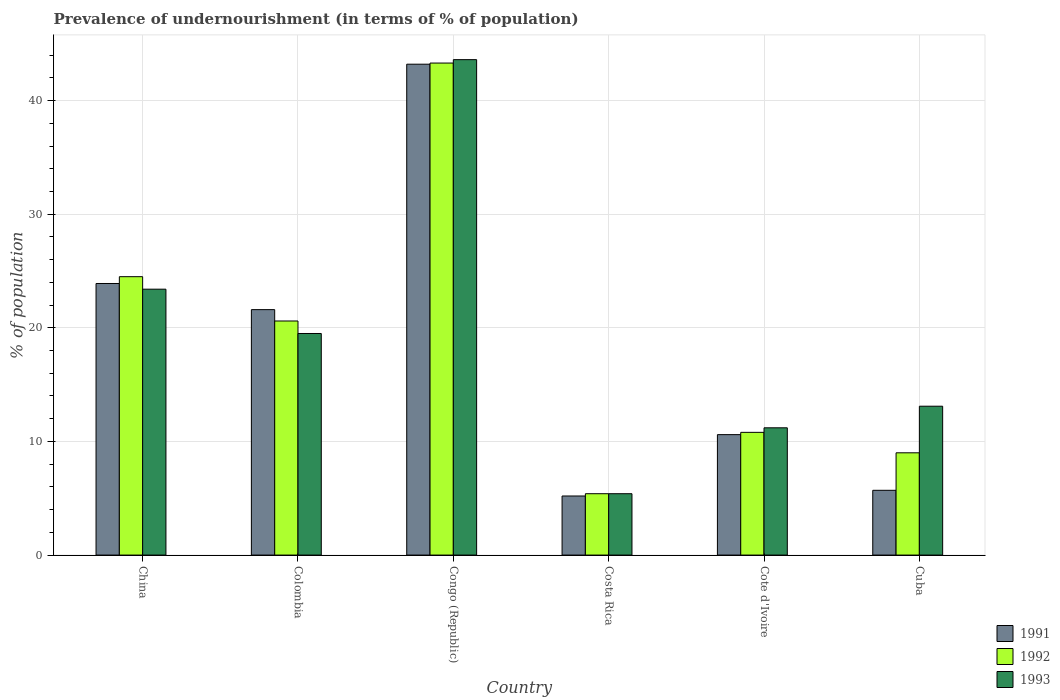Are the number of bars on each tick of the X-axis equal?
Provide a short and direct response. Yes. How many bars are there on the 6th tick from the left?
Ensure brevity in your answer.  3. What is the label of the 5th group of bars from the left?
Give a very brief answer. Cote d'Ivoire. Across all countries, what is the maximum percentage of undernourished population in 1991?
Provide a succinct answer. 43.2. Across all countries, what is the minimum percentage of undernourished population in 1993?
Provide a short and direct response. 5.4. In which country was the percentage of undernourished population in 1992 maximum?
Offer a terse response. Congo (Republic). What is the total percentage of undernourished population in 1992 in the graph?
Offer a terse response. 113.6. What is the difference between the percentage of undernourished population in 1992 in Congo (Republic) and that in Costa Rica?
Provide a short and direct response. 37.9. What is the difference between the percentage of undernourished population in 1991 in Congo (Republic) and the percentage of undernourished population in 1992 in Cote d'Ivoire?
Give a very brief answer. 32.4. What is the average percentage of undernourished population in 1993 per country?
Keep it short and to the point. 19.37. What is the difference between the percentage of undernourished population of/in 1993 and percentage of undernourished population of/in 1991 in Congo (Republic)?
Offer a terse response. 0.4. What is the ratio of the percentage of undernourished population in 1992 in China to that in Colombia?
Give a very brief answer. 1.19. What is the difference between the highest and the second highest percentage of undernourished population in 1993?
Your answer should be very brief. -24.1. What is the difference between the highest and the lowest percentage of undernourished population in 1991?
Give a very brief answer. 38. What does the 3rd bar from the left in Costa Rica represents?
Ensure brevity in your answer.  1993. What does the 3rd bar from the right in Cuba represents?
Offer a terse response. 1991. Is it the case that in every country, the sum of the percentage of undernourished population in 1992 and percentage of undernourished population in 1993 is greater than the percentage of undernourished population in 1991?
Keep it short and to the point. Yes. How many bars are there?
Your answer should be very brief. 18. Does the graph contain any zero values?
Offer a terse response. No. Does the graph contain grids?
Provide a succinct answer. Yes. Where does the legend appear in the graph?
Offer a terse response. Bottom right. How many legend labels are there?
Provide a succinct answer. 3. What is the title of the graph?
Your answer should be compact. Prevalence of undernourishment (in terms of % of population). Does "2002" appear as one of the legend labels in the graph?
Your response must be concise. No. What is the label or title of the X-axis?
Your response must be concise. Country. What is the label or title of the Y-axis?
Your response must be concise. % of population. What is the % of population in 1991 in China?
Offer a terse response. 23.9. What is the % of population of 1993 in China?
Your answer should be compact. 23.4. What is the % of population of 1991 in Colombia?
Give a very brief answer. 21.6. What is the % of population in 1992 in Colombia?
Ensure brevity in your answer.  20.6. What is the % of population in 1991 in Congo (Republic)?
Offer a terse response. 43.2. What is the % of population in 1992 in Congo (Republic)?
Offer a very short reply. 43.3. What is the % of population of 1993 in Congo (Republic)?
Your response must be concise. 43.6. What is the % of population in 1992 in Costa Rica?
Make the answer very short. 5.4. What is the % of population of 1993 in Costa Rica?
Provide a succinct answer. 5.4. What is the % of population of 1991 in Cote d'Ivoire?
Provide a short and direct response. 10.6. What is the % of population in 1993 in Cote d'Ivoire?
Provide a short and direct response. 11.2. What is the % of population of 1991 in Cuba?
Your answer should be very brief. 5.7. What is the % of population of 1992 in Cuba?
Ensure brevity in your answer.  9. What is the % of population of 1993 in Cuba?
Keep it short and to the point. 13.1. Across all countries, what is the maximum % of population of 1991?
Ensure brevity in your answer.  43.2. Across all countries, what is the maximum % of population of 1992?
Keep it short and to the point. 43.3. Across all countries, what is the maximum % of population of 1993?
Offer a very short reply. 43.6. Across all countries, what is the minimum % of population of 1991?
Your answer should be compact. 5.2. Across all countries, what is the minimum % of population in 1993?
Provide a succinct answer. 5.4. What is the total % of population of 1991 in the graph?
Provide a short and direct response. 110.2. What is the total % of population in 1992 in the graph?
Keep it short and to the point. 113.6. What is the total % of population of 1993 in the graph?
Provide a succinct answer. 116.2. What is the difference between the % of population in 1991 in China and that in Congo (Republic)?
Provide a short and direct response. -19.3. What is the difference between the % of population of 1992 in China and that in Congo (Republic)?
Give a very brief answer. -18.8. What is the difference between the % of population of 1993 in China and that in Congo (Republic)?
Keep it short and to the point. -20.2. What is the difference between the % of population of 1991 in China and that in Costa Rica?
Your answer should be very brief. 18.7. What is the difference between the % of population of 1992 in China and that in Costa Rica?
Provide a short and direct response. 19.1. What is the difference between the % of population in 1993 in China and that in Costa Rica?
Your answer should be compact. 18. What is the difference between the % of population in 1992 in China and that in Cote d'Ivoire?
Ensure brevity in your answer.  13.7. What is the difference between the % of population in 1992 in China and that in Cuba?
Offer a very short reply. 15.5. What is the difference between the % of population of 1991 in Colombia and that in Congo (Republic)?
Your answer should be compact. -21.6. What is the difference between the % of population in 1992 in Colombia and that in Congo (Republic)?
Ensure brevity in your answer.  -22.7. What is the difference between the % of population in 1993 in Colombia and that in Congo (Republic)?
Ensure brevity in your answer.  -24.1. What is the difference between the % of population of 1991 in Colombia and that in Cote d'Ivoire?
Your response must be concise. 11. What is the difference between the % of population in 1992 in Colombia and that in Cuba?
Your response must be concise. 11.6. What is the difference between the % of population in 1991 in Congo (Republic) and that in Costa Rica?
Ensure brevity in your answer.  38. What is the difference between the % of population in 1992 in Congo (Republic) and that in Costa Rica?
Your response must be concise. 37.9. What is the difference between the % of population in 1993 in Congo (Republic) and that in Costa Rica?
Keep it short and to the point. 38.2. What is the difference between the % of population in 1991 in Congo (Republic) and that in Cote d'Ivoire?
Your answer should be very brief. 32.6. What is the difference between the % of population in 1992 in Congo (Republic) and that in Cote d'Ivoire?
Offer a terse response. 32.5. What is the difference between the % of population in 1993 in Congo (Republic) and that in Cote d'Ivoire?
Give a very brief answer. 32.4. What is the difference between the % of population of 1991 in Congo (Republic) and that in Cuba?
Your answer should be very brief. 37.5. What is the difference between the % of population in 1992 in Congo (Republic) and that in Cuba?
Keep it short and to the point. 34.3. What is the difference between the % of population in 1993 in Congo (Republic) and that in Cuba?
Your response must be concise. 30.5. What is the difference between the % of population of 1993 in Costa Rica and that in Cote d'Ivoire?
Your response must be concise. -5.8. What is the difference between the % of population in 1991 in Cote d'Ivoire and that in Cuba?
Give a very brief answer. 4.9. What is the difference between the % of population of 1992 in Cote d'Ivoire and that in Cuba?
Make the answer very short. 1.8. What is the difference between the % of population of 1993 in Cote d'Ivoire and that in Cuba?
Make the answer very short. -1.9. What is the difference between the % of population of 1991 in China and the % of population of 1992 in Colombia?
Your response must be concise. 3.3. What is the difference between the % of population in 1992 in China and the % of population in 1993 in Colombia?
Make the answer very short. 5. What is the difference between the % of population in 1991 in China and the % of population in 1992 in Congo (Republic)?
Offer a terse response. -19.4. What is the difference between the % of population of 1991 in China and the % of population of 1993 in Congo (Republic)?
Your answer should be compact. -19.7. What is the difference between the % of population of 1992 in China and the % of population of 1993 in Congo (Republic)?
Provide a succinct answer. -19.1. What is the difference between the % of population of 1991 in China and the % of population of 1992 in Costa Rica?
Keep it short and to the point. 18.5. What is the difference between the % of population of 1991 in China and the % of population of 1993 in Costa Rica?
Make the answer very short. 18.5. What is the difference between the % of population of 1992 in China and the % of population of 1993 in Costa Rica?
Provide a succinct answer. 19.1. What is the difference between the % of population of 1991 in China and the % of population of 1992 in Cote d'Ivoire?
Your response must be concise. 13.1. What is the difference between the % of population in 1991 in China and the % of population in 1993 in Cote d'Ivoire?
Ensure brevity in your answer.  12.7. What is the difference between the % of population of 1991 in China and the % of population of 1992 in Cuba?
Your answer should be compact. 14.9. What is the difference between the % of population in 1991 in China and the % of population in 1993 in Cuba?
Provide a short and direct response. 10.8. What is the difference between the % of population of 1992 in China and the % of population of 1993 in Cuba?
Your response must be concise. 11.4. What is the difference between the % of population in 1991 in Colombia and the % of population in 1992 in Congo (Republic)?
Give a very brief answer. -21.7. What is the difference between the % of population of 1991 in Colombia and the % of population of 1993 in Costa Rica?
Your response must be concise. 16.2. What is the difference between the % of population in 1991 in Colombia and the % of population in 1993 in Cote d'Ivoire?
Provide a succinct answer. 10.4. What is the difference between the % of population in 1992 in Colombia and the % of population in 1993 in Cote d'Ivoire?
Provide a succinct answer. 9.4. What is the difference between the % of population in 1991 in Congo (Republic) and the % of population in 1992 in Costa Rica?
Provide a short and direct response. 37.8. What is the difference between the % of population of 1991 in Congo (Republic) and the % of population of 1993 in Costa Rica?
Make the answer very short. 37.8. What is the difference between the % of population of 1992 in Congo (Republic) and the % of population of 1993 in Costa Rica?
Provide a short and direct response. 37.9. What is the difference between the % of population of 1991 in Congo (Republic) and the % of population of 1992 in Cote d'Ivoire?
Provide a succinct answer. 32.4. What is the difference between the % of population in 1992 in Congo (Republic) and the % of population in 1993 in Cote d'Ivoire?
Offer a terse response. 32.1. What is the difference between the % of population of 1991 in Congo (Republic) and the % of population of 1992 in Cuba?
Offer a very short reply. 34.2. What is the difference between the % of population of 1991 in Congo (Republic) and the % of population of 1993 in Cuba?
Provide a succinct answer. 30.1. What is the difference between the % of population in 1992 in Congo (Republic) and the % of population in 1993 in Cuba?
Offer a terse response. 30.2. What is the difference between the % of population of 1991 in Costa Rica and the % of population of 1993 in Cote d'Ivoire?
Your response must be concise. -6. What is the difference between the % of population of 1991 in Costa Rica and the % of population of 1992 in Cuba?
Your response must be concise. -3.8. What is the difference between the % of population of 1991 in Costa Rica and the % of population of 1993 in Cuba?
Keep it short and to the point. -7.9. What is the difference between the % of population of 1992 in Cote d'Ivoire and the % of population of 1993 in Cuba?
Offer a very short reply. -2.3. What is the average % of population in 1991 per country?
Offer a very short reply. 18.37. What is the average % of population in 1992 per country?
Ensure brevity in your answer.  18.93. What is the average % of population of 1993 per country?
Offer a terse response. 19.37. What is the difference between the % of population of 1992 and % of population of 1993 in Colombia?
Provide a short and direct response. 1.1. What is the difference between the % of population of 1991 and % of population of 1993 in Congo (Republic)?
Make the answer very short. -0.4. What is the difference between the % of population of 1991 and % of population of 1993 in Costa Rica?
Offer a terse response. -0.2. What is the difference between the % of population of 1991 and % of population of 1992 in Cote d'Ivoire?
Provide a short and direct response. -0.2. What is the difference between the % of population in 1991 and % of population in 1993 in Cuba?
Your response must be concise. -7.4. What is the ratio of the % of population of 1991 in China to that in Colombia?
Your answer should be compact. 1.11. What is the ratio of the % of population of 1992 in China to that in Colombia?
Your response must be concise. 1.19. What is the ratio of the % of population of 1993 in China to that in Colombia?
Give a very brief answer. 1.2. What is the ratio of the % of population of 1991 in China to that in Congo (Republic)?
Give a very brief answer. 0.55. What is the ratio of the % of population in 1992 in China to that in Congo (Republic)?
Provide a short and direct response. 0.57. What is the ratio of the % of population of 1993 in China to that in Congo (Republic)?
Give a very brief answer. 0.54. What is the ratio of the % of population in 1991 in China to that in Costa Rica?
Offer a terse response. 4.6. What is the ratio of the % of population of 1992 in China to that in Costa Rica?
Provide a short and direct response. 4.54. What is the ratio of the % of population in 1993 in China to that in Costa Rica?
Offer a very short reply. 4.33. What is the ratio of the % of population of 1991 in China to that in Cote d'Ivoire?
Your answer should be compact. 2.25. What is the ratio of the % of population of 1992 in China to that in Cote d'Ivoire?
Offer a very short reply. 2.27. What is the ratio of the % of population of 1993 in China to that in Cote d'Ivoire?
Your answer should be very brief. 2.09. What is the ratio of the % of population in 1991 in China to that in Cuba?
Your response must be concise. 4.19. What is the ratio of the % of population of 1992 in China to that in Cuba?
Keep it short and to the point. 2.72. What is the ratio of the % of population in 1993 in China to that in Cuba?
Make the answer very short. 1.79. What is the ratio of the % of population in 1992 in Colombia to that in Congo (Republic)?
Keep it short and to the point. 0.48. What is the ratio of the % of population in 1993 in Colombia to that in Congo (Republic)?
Offer a very short reply. 0.45. What is the ratio of the % of population of 1991 in Colombia to that in Costa Rica?
Give a very brief answer. 4.15. What is the ratio of the % of population in 1992 in Colombia to that in Costa Rica?
Keep it short and to the point. 3.81. What is the ratio of the % of population in 1993 in Colombia to that in Costa Rica?
Ensure brevity in your answer.  3.61. What is the ratio of the % of population of 1991 in Colombia to that in Cote d'Ivoire?
Provide a short and direct response. 2.04. What is the ratio of the % of population of 1992 in Colombia to that in Cote d'Ivoire?
Give a very brief answer. 1.91. What is the ratio of the % of population in 1993 in Colombia to that in Cote d'Ivoire?
Your response must be concise. 1.74. What is the ratio of the % of population of 1991 in Colombia to that in Cuba?
Keep it short and to the point. 3.79. What is the ratio of the % of population in 1992 in Colombia to that in Cuba?
Your response must be concise. 2.29. What is the ratio of the % of population in 1993 in Colombia to that in Cuba?
Your answer should be very brief. 1.49. What is the ratio of the % of population of 1991 in Congo (Republic) to that in Costa Rica?
Your answer should be compact. 8.31. What is the ratio of the % of population in 1992 in Congo (Republic) to that in Costa Rica?
Your response must be concise. 8.02. What is the ratio of the % of population in 1993 in Congo (Republic) to that in Costa Rica?
Provide a succinct answer. 8.07. What is the ratio of the % of population of 1991 in Congo (Republic) to that in Cote d'Ivoire?
Offer a terse response. 4.08. What is the ratio of the % of population in 1992 in Congo (Republic) to that in Cote d'Ivoire?
Provide a succinct answer. 4.01. What is the ratio of the % of population in 1993 in Congo (Republic) to that in Cote d'Ivoire?
Keep it short and to the point. 3.89. What is the ratio of the % of population in 1991 in Congo (Republic) to that in Cuba?
Your answer should be very brief. 7.58. What is the ratio of the % of population in 1992 in Congo (Republic) to that in Cuba?
Provide a succinct answer. 4.81. What is the ratio of the % of population in 1993 in Congo (Republic) to that in Cuba?
Your answer should be very brief. 3.33. What is the ratio of the % of population of 1991 in Costa Rica to that in Cote d'Ivoire?
Your answer should be compact. 0.49. What is the ratio of the % of population in 1992 in Costa Rica to that in Cote d'Ivoire?
Your response must be concise. 0.5. What is the ratio of the % of population of 1993 in Costa Rica to that in Cote d'Ivoire?
Ensure brevity in your answer.  0.48. What is the ratio of the % of population of 1991 in Costa Rica to that in Cuba?
Provide a short and direct response. 0.91. What is the ratio of the % of population in 1992 in Costa Rica to that in Cuba?
Your answer should be very brief. 0.6. What is the ratio of the % of population of 1993 in Costa Rica to that in Cuba?
Make the answer very short. 0.41. What is the ratio of the % of population in 1991 in Cote d'Ivoire to that in Cuba?
Provide a succinct answer. 1.86. What is the ratio of the % of population in 1992 in Cote d'Ivoire to that in Cuba?
Provide a succinct answer. 1.2. What is the ratio of the % of population in 1993 in Cote d'Ivoire to that in Cuba?
Your answer should be compact. 0.85. What is the difference between the highest and the second highest % of population in 1991?
Your response must be concise. 19.3. What is the difference between the highest and the second highest % of population in 1993?
Your answer should be compact. 20.2. What is the difference between the highest and the lowest % of population of 1992?
Your response must be concise. 37.9. What is the difference between the highest and the lowest % of population of 1993?
Make the answer very short. 38.2. 